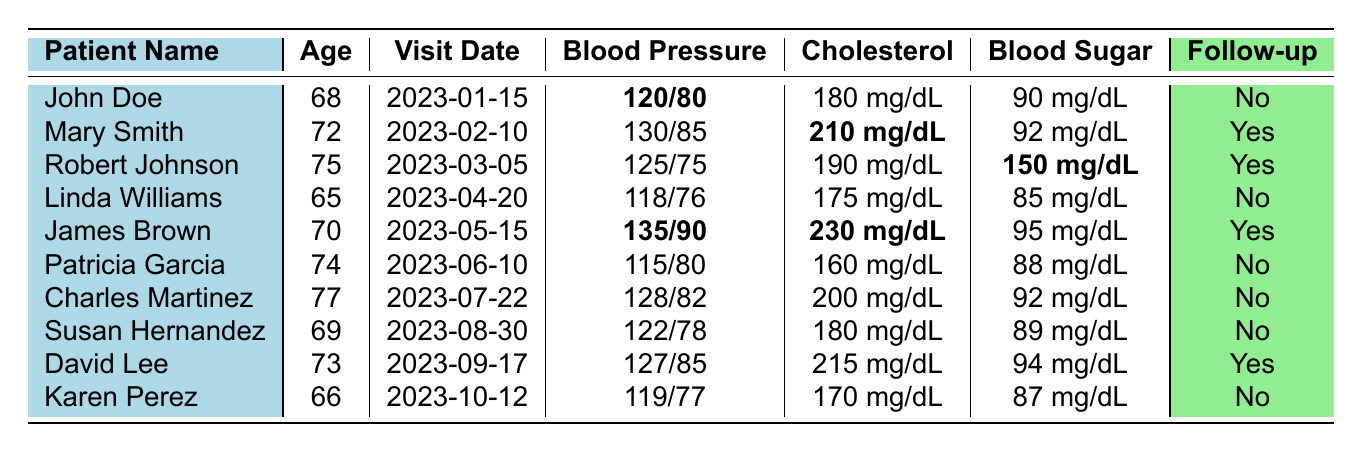What is the blood pressure of John Doe? In the table, under John Doe's entry, the blood pressure is stated as 120/80.
Answer: 120/80 How many patients needed a follow-up after their visit? The table shows that follow-up is needed for Mary Smith, Robert Johnson, James Brown, and David Lee. Counting these entries gives a total of 4 patients requiring follow-up.
Answer: 4 What is the cholesterol level of Robert Johnson? The table indicates that Robert Johnson's cholesterol level is 190 mg/dL.
Answer: 190 mg/dL Which patient had the highest blood sugar level? By checking the blood sugar levels in the table, Robert Johnson has the highest level at 150 mg/dL.
Answer: Robert Johnson Did Linda Williams need a follow-up after her visit? Looking at Linda Williams's entry, it states "No" for follow-up needed.
Answer: No What is the average age of the patients listed? To find the average age, we first sum the ages: (68 + 72 + 75 + 65 + 70 + 74 + 77 + 69 + 73 + 66) =  740. Dividing this by the 10 patients gives an average age of 74.
Answer: 74 Which patient had a visit for a heart health check? The table specifies that James Brown had a visit for a heart health check on May 15, 2023.
Answer: James Brown Are there any patients with a cholesterol level above 200 mg/dL? Yes, the table shows that James Brown has a cholesterol level of 230 mg/dL, which is above 200 mg/dL.
Answer: Yes What is the difference between the highest and lowest blood pressure recorded? The highest blood pressure is from James Brown at 135/90, and the lowest is from Linda Williams at 118/76. Converting these to decimal form for comparison: 135/90 as 135 & 90, and 118/76 as 118 & 76. The systolic (135 - 118) is 17, and diastolic (90 - 76) is 14 which shows the systolic difference is larger.
Answer: Systolic 17, Diastolic 14 How many patients had a "No" for follow-up needed? Counting the entries with "No" for follow-up: John Doe, Linda Williams, Patricia Garcia, Charles Martinez, Susan Hernandez, and Karen Perez results in 6 instances.
Answer: 6 What were the reasons for the visits of the patients who needed follow-ups? The patients needing follow-ups had reasons: Mary Smith (Routine Checkup), Robert Johnson (Follow-up for Diabetes), James Brown (Heart Health Check), and David Lee (Knee Pain Consultation).
Answer: Routine Checkup, Follow-up for Diabetes, Heart Health Check, Knee Pain Consultation 